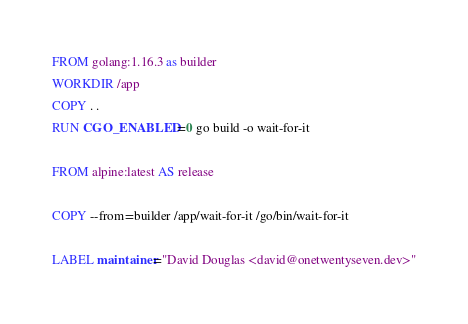<code> <loc_0><loc_0><loc_500><loc_500><_Dockerfile_>FROM golang:1.16.3 as builder
WORKDIR /app
COPY . .
RUN CGO_ENABLED=0 go build -o wait-for-it 

FROM alpine:latest AS release

COPY --from=builder /app/wait-for-it /go/bin/wait-for-it

LABEL maintainer="David Douglas <david@onetwentyseven.dev>"</code> 